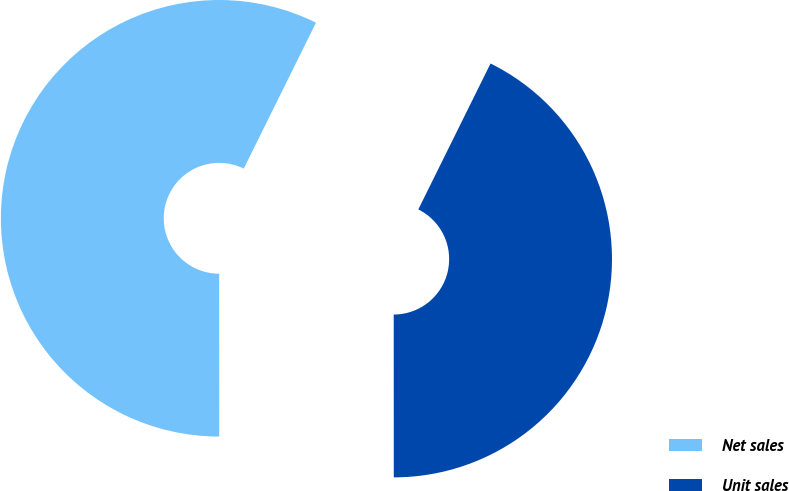Convert chart to OTSL. <chart><loc_0><loc_0><loc_500><loc_500><pie_chart><fcel>Net sales<fcel>Unit sales<nl><fcel>57.32%<fcel>42.68%<nl></chart> 